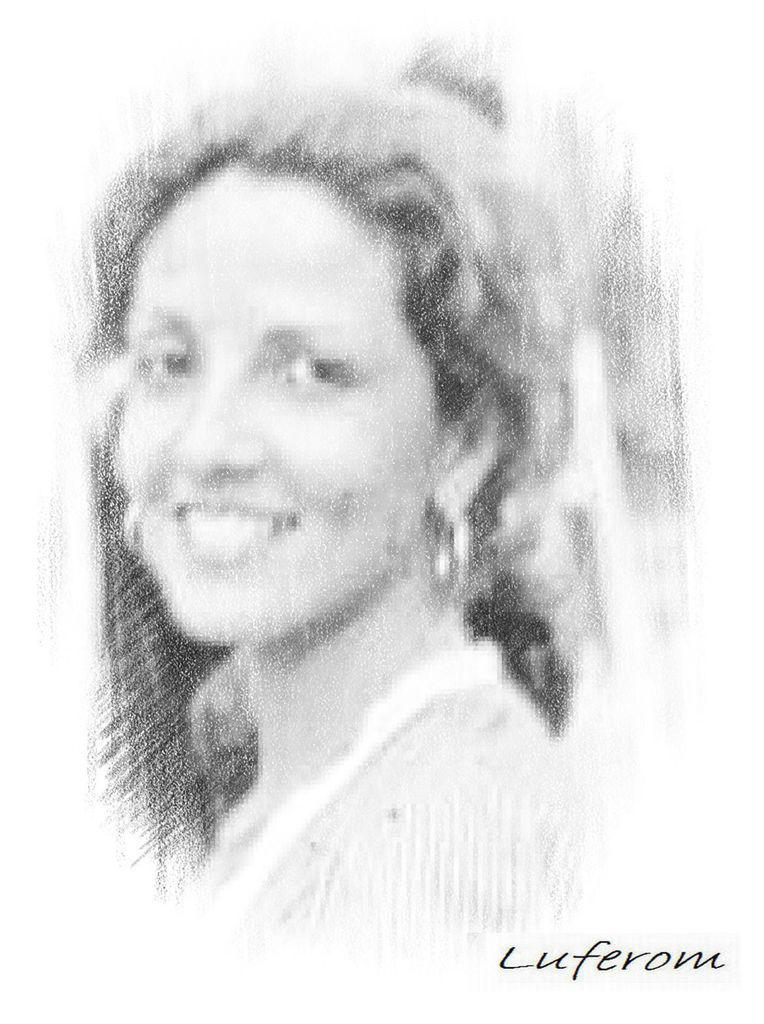What is depicted in the image? The image contains a sketch of a woman. What is the facial expression of the woman in the sketch? The woman in the sketch is smiling. Is there any additional marking or feature in the image? Yes, there is a watermark in the image. What is the color of the background in the image? The background of the image is white. What type of quartz can be seen in the woman's hand in the image? There is no quartz present in the image; it is a sketch of a woman with no objects in her hand. How many times does the woman twist her hair in the image? There is no indication of the woman twisting her hair in the image; she is simply smiling in the sketch. 